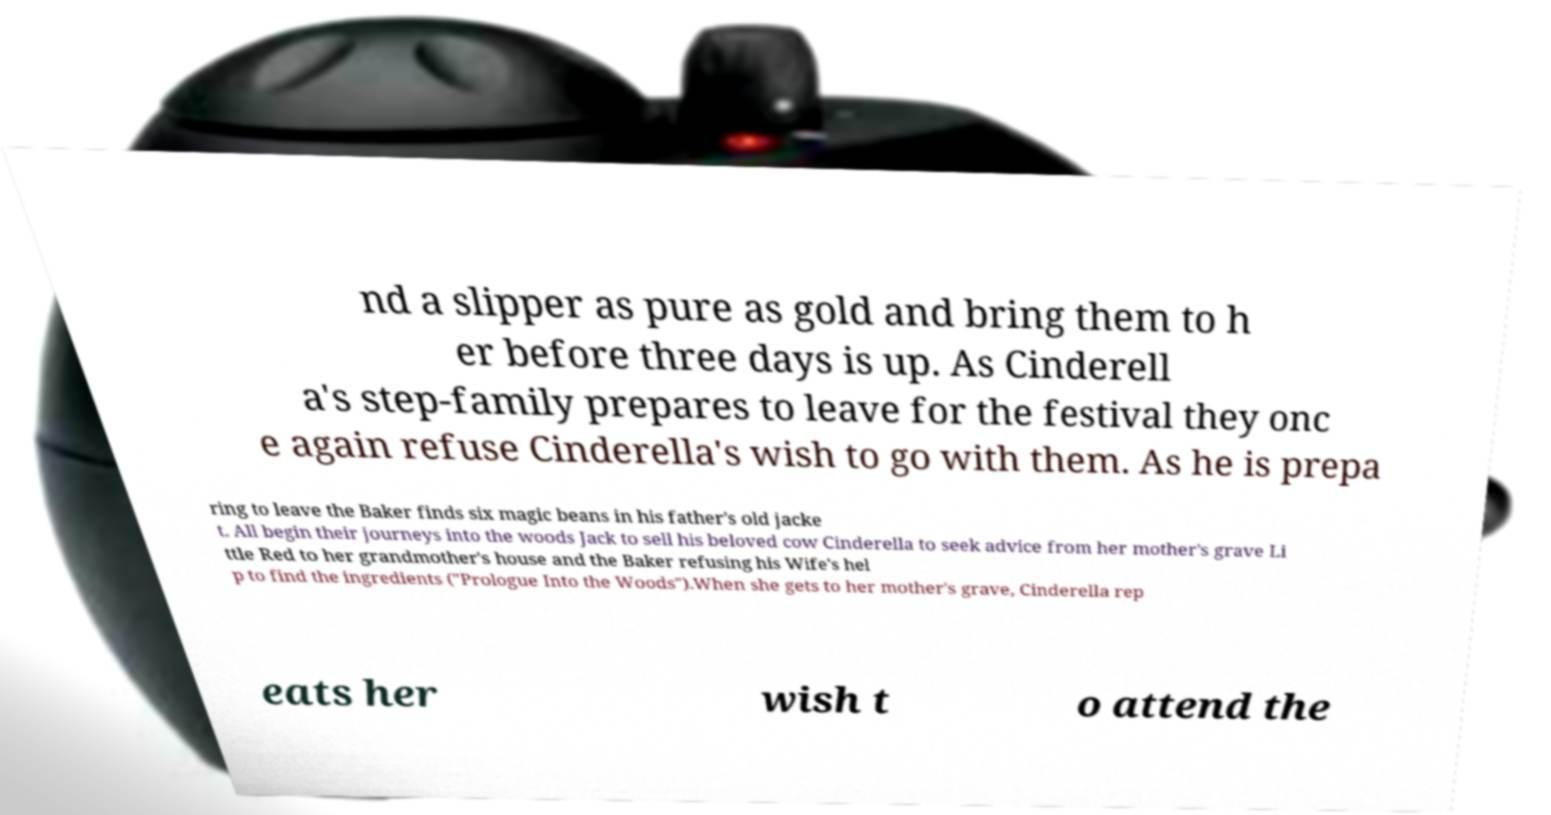Please read and relay the text visible in this image. What does it say? nd a slipper as pure as gold and bring them to h er before three days is up. As Cinderell a's step-family prepares to leave for the festival they onc e again refuse Cinderella's wish to go with them. As he is prepa ring to leave the Baker finds six magic beans in his father's old jacke t. All begin their journeys into the woods Jack to sell his beloved cow Cinderella to seek advice from her mother's grave Li ttle Red to her grandmother's house and the Baker refusing his Wife's hel p to find the ingredients ("Prologue Into the Woods").When she gets to her mother's grave, Cinderella rep eats her wish t o attend the 